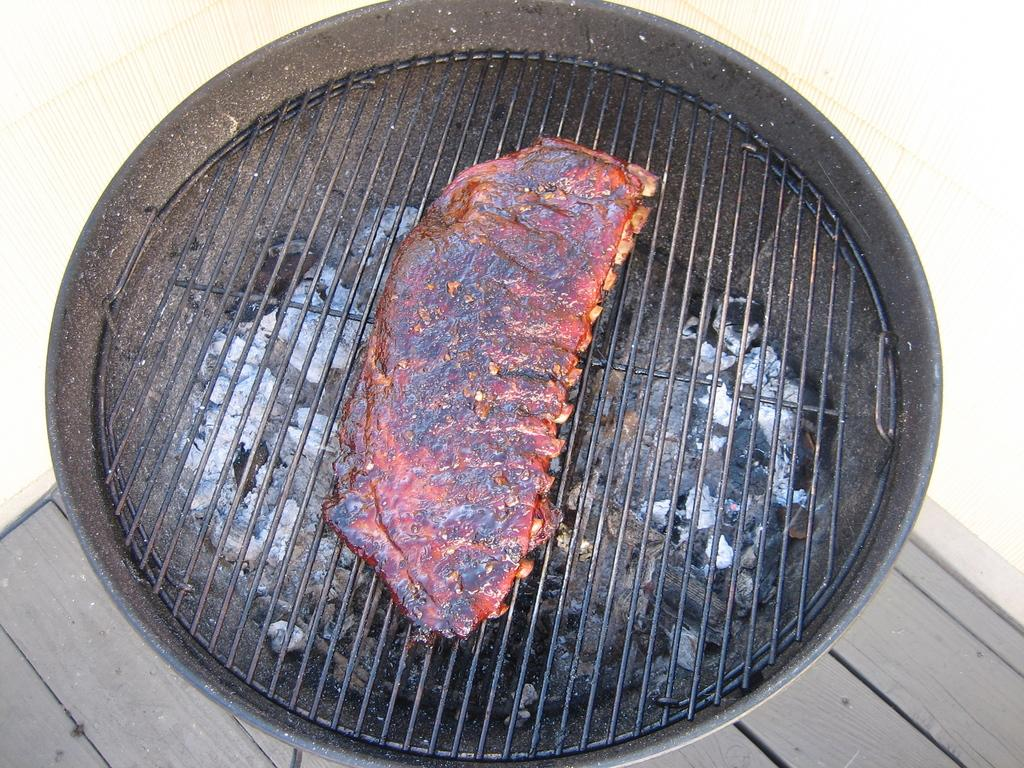What type of cooking appliance is in the image? There is a charcoal grill in the image. What is the charcoal grill placed on? The charcoal grill is on a wooden surface. What is being cooked on the grill? There is meat on the grill. What can be seen in the background of the image? There is a wall visible in the background of the image. Can you see your dad standing next to the volcano in the image? There is no volcano or person present in the image; it features a charcoal grill with meat on it and a wall in the background. 